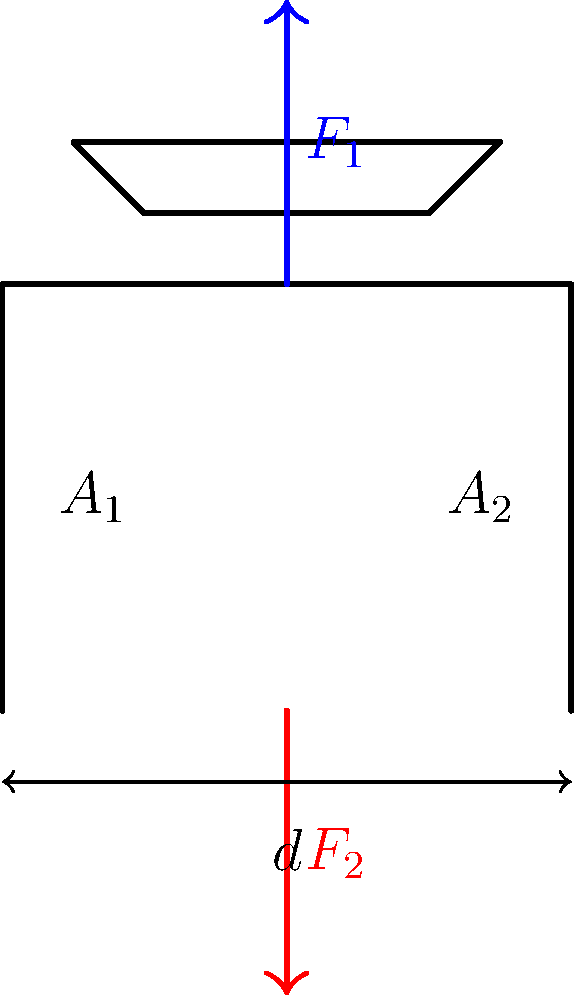As a ground handler interested in improving working conditions, you're analyzing a hydraulic lift used for aircraft maintenance. The lift has two cylinders with cross-sectional areas $A_1 = 0.1 \text{ m}^2$ and $A_2 = 0.5 \text{ m}^2$, respectively. If a force $F_2 = 50,000 \text{ N}$ is applied to the smaller cylinder, what is the maximum weight of an aircraft ($F_1$) that can be lifted, assuming ideal conditions and neglecting the weight of the lift itself? To solve this problem, we'll use Pascal's principle, which states that pressure is transmitted equally throughout a confined fluid. Let's follow these steps:

1) According to Pascal's principle, the pressure in both cylinders is equal:

   $$P_1 = P_2$$

2) Pressure is defined as force per unit area:

   $$\frac{F_1}{A_1} = \frac{F_2}{A_2}$$

3) We can rearrange this equation to solve for $F_1$:

   $$F_1 = F_2 \cdot \frac{A_1}{A_2}$$

4) Now, let's substitute the known values:
   $F_2 = 50,000 \text{ N}$
   $A_1 = 0.1 \text{ m}^2$
   $A_2 = 0.5 \text{ m}^2$

   $$F_1 = 50,000 \text{ N} \cdot \frac{0.5 \text{ m}^2}{0.1 \text{ m}^2}$$

5) Simplify:

   $$F_1 = 50,000 \text{ N} \cdot 5 = 250,000 \text{ N}$$

Therefore, the maximum weight of the aircraft that can be lifted is 250,000 N or 250 kN.
Answer: 250 kN 